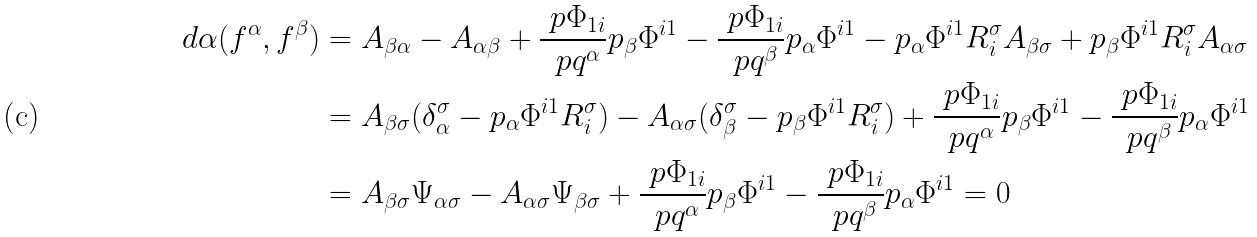<formula> <loc_0><loc_0><loc_500><loc_500>d \alpha ( f ^ { \alpha } , f ^ { \beta } ) & = A _ { \beta \alpha } - A _ { \alpha \beta } + \frac { \ p \Phi _ { 1 i } } { \ p q ^ { \alpha } } p _ { \beta } \Phi ^ { i 1 } - \frac { \ p \Phi _ { 1 i } } { \ p q ^ { \beta } } p _ { \alpha } \Phi ^ { i 1 } - p _ { \alpha } \Phi ^ { i 1 } R ^ { \sigma } _ { i } A _ { \beta \sigma } + p _ { \beta } \Phi ^ { i 1 } R ^ { \sigma } _ { i } A _ { \alpha \sigma } \\ & = A _ { \beta \sigma } ( \delta ^ { \sigma } _ { \alpha } - p _ { \alpha } \Phi ^ { i 1 } R ^ { \sigma } _ { i } ) - A _ { \alpha \sigma } ( \delta ^ { \sigma } _ { \beta } - p _ { \beta } \Phi ^ { i 1 } R ^ { \sigma } _ { i } ) + \frac { \ p \Phi _ { 1 i } } { \ p q ^ { \alpha } } p _ { \beta } \Phi ^ { i 1 } - \frac { \ p \Phi _ { 1 i } } { \ p q ^ { \beta } } p _ { \alpha } \Phi ^ { i 1 } \\ & = A _ { \beta \sigma } \Psi _ { \alpha \sigma } - A _ { \alpha \sigma } \Psi _ { \beta \sigma } + \frac { \ p \Phi _ { 1 i } } { \ p q ^ { \alpha } } p _ { \beta } \Phi ^ { i 1 } - \frac { \ p \Phi _ { 1 i } } { \ p q ^ { \beta } } p _ { \alpha } \Phi ^ { i 1 } = 0</formula> 